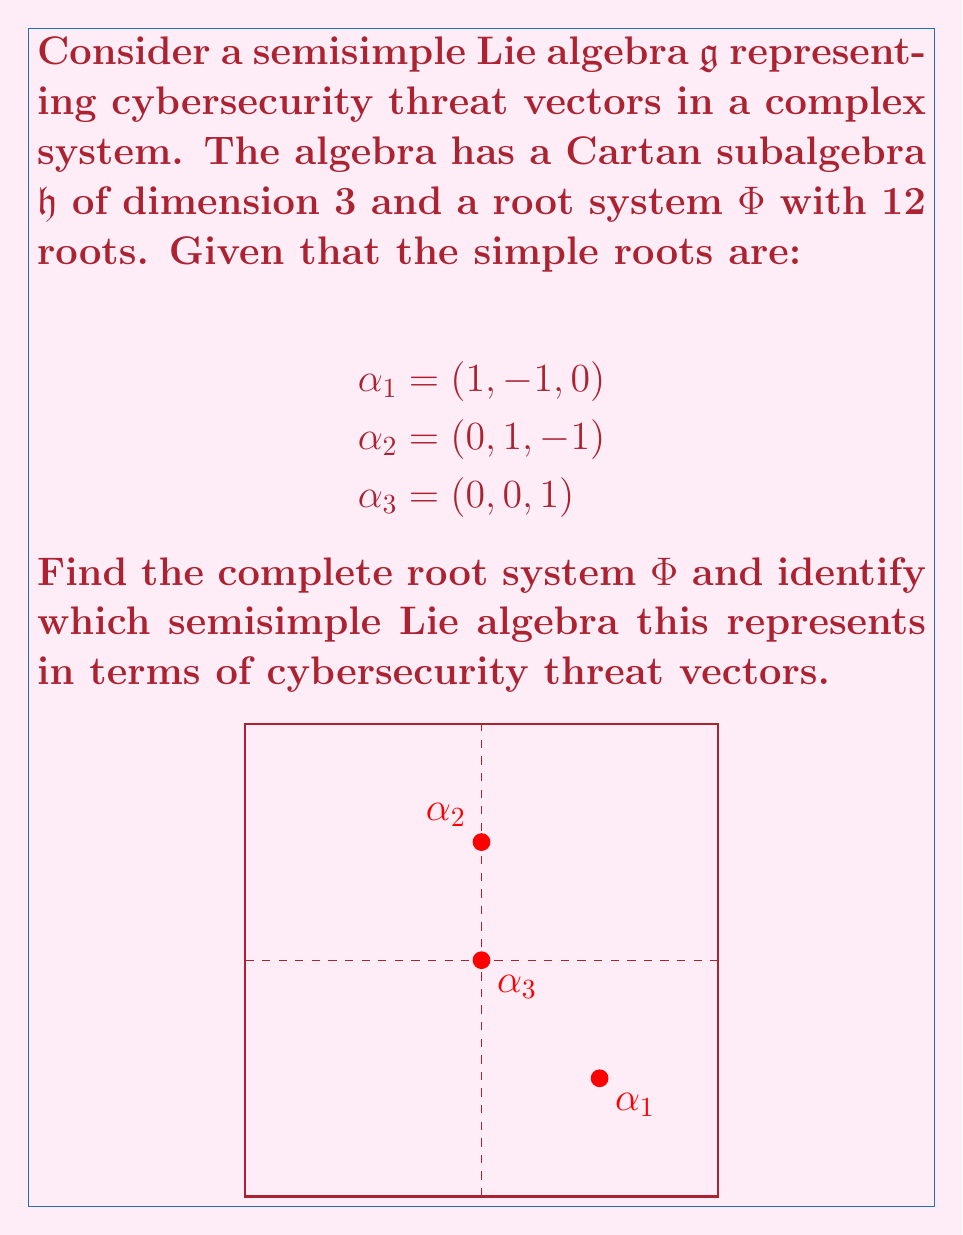Teach me how to tackle this problem. Let's approach this step-by-step:

1) First, we need to generate all positive roots using linear combinations of the simple roots:

   $\alpha_1 = (1, -1, 0)$
   $\alpha_2 = (0, 1, -1)$
   $\alpha_3 = (0, 0, 1)$
   $\alpha_1 + \alpha_2 = (1, 0, -1)$
   $\alpha_2 + \alpha_3 = (0, 1, 0)$
   $\alpha_1 + \alpha_2 + \alpha_3 = (1, 0, 0)$

2) The negative roots are just the negatives of these:

   $-\alpha_1 = (-1, 1, 0)$
   $-\alpha_2 = (0, -1, 1)$
   $-\alpha_3 = (0, 0, -1)$
   $-(\alpha_1 + \alpha_2) = (-1, 0, 1)$
   $-(\alpha_2 + \alpha_3) = (0, -1, 0)$
   $-(\alpha_1 + \alpha_2 + \alpha_3) = (-1, 0, 0)$

3) The complete root system $\Phi$ is the union of positive and negative roots, giving us 12 roots in total.

4) This root system corresponds to the Lie algebra $A_3$, which is isomorphic to $\mathfrak{sl}(4, \mathbb{C})$.

5) In terms of cybersecurity threat vectors, we can interpret this as follows:

   - The 3-dimensional Cartan subalgebra represents three primary categories of cyber threats: $\mathfrak{h}_1$ (e.g., network attacks), $\mathfrak{h}_2$ (e.g., application attacks), and $\mathfrak{h}_3$ (e.g., social engineering).
   
   - Each root represents a specific type of threat vector, with positive roots indicating offensive capabilities and negative roots representing defensive measures.
   
   - The simple roots $\alpha_1$, $\alpha_2$, and $\alpha_3$ represent fundamental threat types that can be combined to form more complex attack vectors.
   
   - The highest root $\alpha_1 + \alpha_2 + \alpha_3 = (1, 0, 0)$ could represent a sophisticated, multi-layered attack combining all three primary threat categories.

This $A_3$ structure provides a framework for analyzing and categorizing cybersecurity threats in a complex system, allowing for strategic risk management and defense planning.
Answer: $\Phi = \{\pm(1,-1,0), \pm(0,1,-1), \pm(0,0,1), \pm(1,0,-1), \pm(0,1,0), \pm(1,0,0)\}$; $A_3 \cong \mathfrak{sl}(4, \mathbb{C})$ 